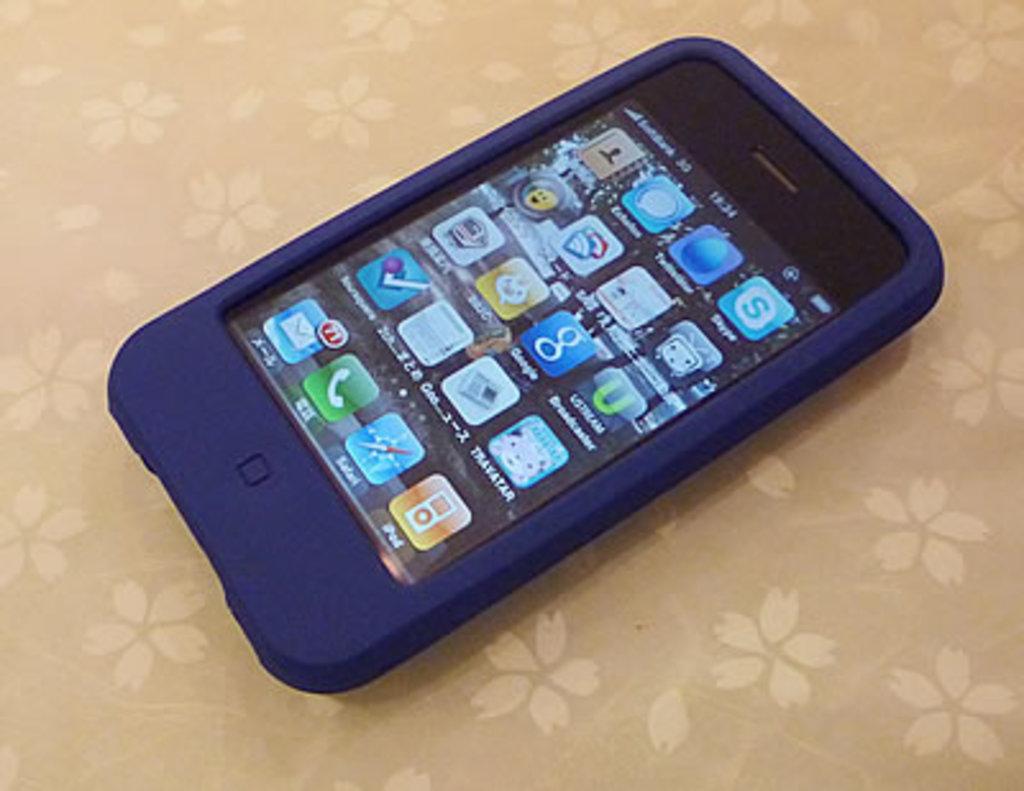What brand of phone is this?
Your answer should be compact. Unanswerable. What app is on the far bottom right?
Provide a succinct answer. Ipod. 